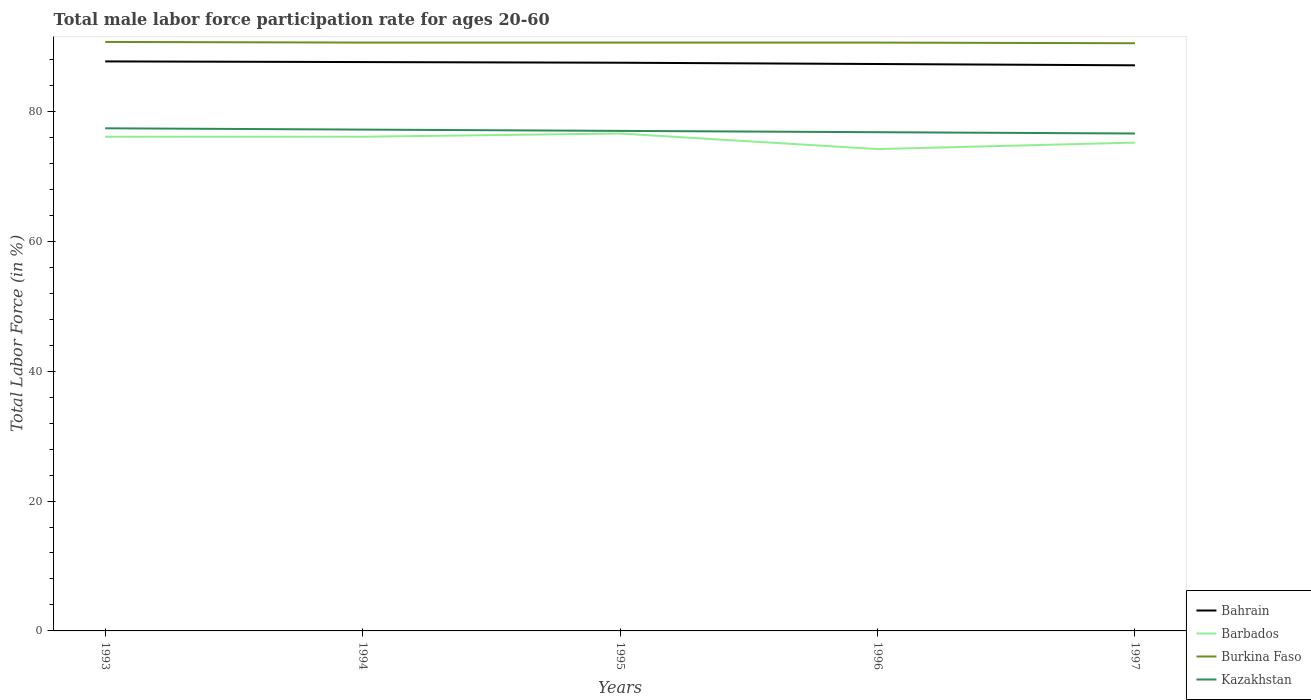How many different coloured lines are there?
Ensure brevity in your answer.  4. Does the line corresponding to Bahrain intersect with the line corresponding to Barbados?
Your answer should be very brief. No. Is the number of lines equal to the number of legend labels?
Provide a short and direct response. Yes. Across all years, what is the maximum male labor force participation rate in Kazakhstan?
Your answer should be compact. 76.6. What is the total male labor force participation rate in Barbados in the graph?
Ensure brevity in your answer.  0.9. What is the difference between the highest and the second highest male labor force participation rate in Burkina Faso?
Provide a succinct answer. 0.2. Is the male labor force participation rate in Burkina Faso strictly greater than the male labor force participation rate in Bahrain over the years?
Provide a short and direct response. No. What is the difference between two consecutive major ticks on the Y-axis?
Ensure brevity in your answer.  20. How many legend labels are there?
Offer a terse response. 4. What is the title of the graph?
Your answer should be compact. Total male labor force participation rate for ages 20-60. Does "United Arab Emirates" appear as one of the legend labels in the graph?
Offer a very short reply. No. What is the label or title of the Y-axis?
Your answer should be compact. Total Labor Force (in %). What is the Total Labor Force (in %) of Bahrain in 1993?
Offer a very short reply. 87.7. What is the Total Labor Force (in %) in Barbados in 1993?
Provide a succinct answer. 76.1. What is the Total Labor Force (in %) of Burkina Faso in 1993?
Provide a succinct answer. 90.7. What is the Total Labor Force (in %) of Kazakhstan in 1993?
Offer a terse response. 77.4. What is the Total Labor Force (in %) of Bahrain in 1994?
Give a very brief answer. 87.6. What is the Total Labor Force (in %) in Barbados in 1994?
Provide a succinct answer. 76.1. What is the Total Labor Force (in %) of Burkina Faso in 1994?
Your response must be concise. 90.6. What is the Total Labor Force (in %) in Kazakhstan in 1994?
Make the answer very short. 77.2. What is the Total Labor Force (in %) in Bahrain in 1995?
Keep it short and to the point. 87.5. What is the Total Labor Force (in %) in Barbados in 1995?
Provide a succinct answer. 76.6. What is the Total Labor Force (in %) in Burkina Faso in 1995?
Your response must be concise. 90.6. What is the Total Labor Force (in %) in Kazakhstan in 1995?
Your answer should be compact. 77. What is the Total Labor Force (in %) in Bahrain in 1996?
Offer a terse response. 87.3. What is the Total Labor Force (in %) of Barbados in 1996?
Offer a very short reply. 74.2. What is the Total Labor Force (in %) of Burkina Faso in 1996?
Ensure brevity in your answer.  90.6. What is the Total Labor Force (in %) in Kazakhstan in 1996?
Give a very brief answer. 76.8. What is the Total Labor Force (in %) in Bahrain in 1997?
Your response must be concise. 87.1. What is the Total Labor Force (in %) of Barbados in 1997?
Provide a short and direct response. 75.2. What is the Total Labor Force (in %) in Burkina Faso in 1997?
Ensure brevity in your answer.  90.5. What is the Total Labor Force (in %) in Kazakhstan in 1997?
Your response must be concise. 76.6. Across all years, what is the maximum Total Labor Force (in %) in Bahrain?
Give a very brief answer. 87.7. Across all years, what is the maximum Total Labor Force (in %) in Barbados?
Give a very brief answer. 76.6. Across all years, what is the maximum Total Labor Force (in %) of Burkina Faso?
Ensure brevity in your answer.  90.7. Across all years, what is the maximum Total Labor Force (in %) in Kazakhstan?
Offer a terse response. 77.4. Across all years, what is the minimum Total Labor Force (in %) in Bahrain?
Provide a short and direct response. 87.1. Across all years, what is the minimum Total Labor Force (in %) of Barbados?
Your response must be concise. 74.2. Across all years, what is the minimum Total Labor Force (in %) of Burkina Faso?
Keep it short and to the point. 90.5. Across all years, what is the minimum Total Labor Force (in %) in Kazakhstan?
Offer a terse response. 76.6. What is the total Total Labor Force (in %) of Bahrain in the graph?
Make the answer very short. 437.2. What is the total Total Labor Force (in %) of Barbados in the graph?
Your answer should be very brief. 378.2. What is the total Total Labor Force (in %) in Burkina Faso in the graph?
Offer a terse response. 453. What is the total Total Labor Force (in %) in Kazakhstan in the graph?
Your answer should be very brief. 385. What is the difference between the Total Labor Force (in %) of Bahrain in 1993 and that in 1994?
Your answer should be compact. 0.1. What is the difference between the Total Labor Force (in %) in Barbados in 1993 and that in 1995?
Ensure brevity in your answer.  -0.5. What is the difference between the Total Labor Force (in %) of Kazakhstan in 1993 and that in 1995?
Your answer should be very brief. 0.4. What is the difference between the Total Labor Force (in %) in Kazakhstan in 1993 and that in 1996?
Provide a succinct answer. 0.6. What is the difference between the Total Labor Force (in %) in Bahrain in 1993 and that in 1997?
Your answer should be very brief. 0.6. What is the difference between the Total Labor Force (in %) in Bahrain in 1994 and that in 1995?
Your answer should be very brief. 0.1. What is the difference between the Total Labor Force (in %) in Barbados in 1994 and that in 1995?
Keep it short and to the point. -0.5. What is the difference between the Total Labor Force (in %) of Burkina Faso in 1994 and that in 1996?
Provide a succinct answer. 0. What is the difference between the Total Labor Force (in %) in Kazakhstan in 1994 and that in 1996?
Provide a short and direct response. 0.4. What is the difference between the Total Labor Force (in %) of Bahrain in 1995 and that in 1996?
Keep it short and to the point. 0.2. What is the difference between the Total Labor Force (in %) in Barbados in 1995 and that in 1996?
Your response must be concise. 2.4. What is the difference between the Total Labor Force (in %) in Kazakhstan in 1995 and that in 1996?
Provide a succinct answer. 0.2. What is the difference between the Total Labor Force (in %) in Barbados in 1995 and that in 1997?
Keep it short and to the point. 1.4. What is the difference between the Total Labor Force (in %) in Kazakhstan in 1995 and that in 1997?
Your answer should be compact. 0.4. What is the difference between the Total Labor Force (in %) of Bahrain in 1996 and that in 1997?
Ensure brevity in your answer.  0.2. What is the difference between the Total Labor Force (in %) in Barbados in 1996 and that in 1997?
Your response must be concise. -1. What is the difference between the Total Labor Force (in %) in Burkina Faso in 1996 and that in 1997?
Make the answer very short. 0.1. What is the difference between the Total Labor Force (in %) of Bahrain in 1993 and the Total Labor Force (in %) of Barbados in 1994?
Ensure brevity in your answer.  11.6. What is the difference between the Total Labor Force (in %) of Barbados in 1993 and the Total Labor Force (in %) of Burkina Faso in 1994?
Give a very brief answer. -14.5. What is the difference between the Total Labor Force (in %) in Barbados in 1993 and the Total Labor Force (in %) in Kazakhstan in 1994?
Keep it short and to the point. -1.1. What is the difference between the Total Labor Force (in %) in Burkina Faso in 1993 and the Total Labor Force (in %) in Kazakhstan in 1994?
Your answer should be very brief. 13.5. What is the difference between the Total Labor Force (in %) in Bahrain in 1993 and the Total Labor Force (in %) in Barbados in 1995?
Provide a short and direct response. 11.1. What is the difference between the Total Labor Force (in %) of Bahrain in 1993 and the Total Labor Force (in %) of Kazakhstan in 1995?
Keep it short and to the point. 10.7. What is the difference between the Total Labor Force (in %) in Barbados in 1993 and the Total Labor Force (in %) in Burkina Faso in 1995?
Make the answer very short. -14.5. What is the difference between the Total Labor Force (in %) of Barbados in 1993 and the Total Labor Force (in %) of Kazakhstan in 1995?
Ensure brevity in your answer.  -0.9. What is the difference between the Total Labor Force (in %) of Bahrain in 1993 and the Total Labor Force (in %) of Burkina Faso in 1996?
Provide a short and direct response. -2.9. What is the difference between the Total Labor Force (in %) in Bahrain in 1993 and the Total Labor Force (in %) in Kazakhstan in 1996?
Your response must be concise. 10.9. What is the difference between the Total Labor Force (in %) in Barbados in 1993 and the Total Labor Force (in %) in Kazakhstan in 1996?
Give a very brief answer. -0.7. What is the difference between the Total Labor Force (in %) in Burkina Faso in 1993 and the Total Labor Force (in %) in Kazakhstan in 1996?
Keep it short and to the point. 13.9. What is the difference between the Total Labor Force (in %) of Bahrain in 1993 and the Total Labor Force (in %) of Barbados in 1997?
Provide a short and direct response. 12.5. What is the difference between the Total Labor Force (in %) of Bahrain in 1993 and the Total Labor Force (in %) of Burkina Faso in 1997?
Your answer should be very brief. -2.8. What is the difference between the Total Labor Force (in %) in Barbados in 1993 and the Total Labor Force (in %) in Burkina Faso in 1997?
Your answer should be very brief. -14.4. What is the difference between the Total Labor Force (in %) of Barbados in 1993 and the Total Labor Force (in %) of Kazakhstan in 1997?
Provide a short and direct response. -0.5. What is the difference between the Total Labor Force (in %) in Burkina Faso in 1993 and the Total Labor Force (in %) in Kazakhstan in 1997?
Your answer should be compact. 14.1. What is the difference between the Total Labor Force (in %) of Bahrain in 1994 and the Total Labor Force (in %) of Barbados in 1995?
Make the answer very short. 11. What is the difference between the Total Labor Force (in %) in Bahrain in 1994 and the Total Labor Force (in %) in Burkina Faso in 1995?
Ensure brevity in your answer.  -3. What is the difference between the Total Labor Force (in %) of Barbados in 1994 and the Total Labor Force (in %) of Burkina Faso in 1995?
Provide a succinct answer. -14.5. What is the difference between the Total Labor Force (in %) of Barbados in 1994 and the Total Labor Force (in %) of Kazakhstan in 1995?
Ensure brevity in your answer.  -0.9. What is the difference between the Total Labor Force (in %) in Burkina Faso in 1994 and the Total Labor Force (in %) in Kazakhstan in 1995?
Give a very brief answer. 13.6. What is the difference between the Total Labor Force (in %) in Bahrain in 1994 and the Total Labor Force (in %) in Burkina Faso in 1996?
Your answer should be very brief. -3. What is the difference between the Total Labor Force (in %) of Bahrain in 1994 and the Total Labor Force (in %) of Kazakhstan in 1996?
Make the answer very short. 10.8. What is the difference between the Total Labor Force (in %) of Barbados in 1994 and the Total Labor Force (in %) of Kazakhstan in 1996?
Make the answer very short. -0.7. What is the difference between the Total Labor Force (in %) in Burkina Faso in 1994 and the Total Labor Force (in %) in Kazakhstan in 1996?
Ensure brevity in your answer.  13.8. What is the difference between the Total Labor Force (in %) in Bahrain in 1994 and the Total Labor Force (in %) in Barbados in 1997?
Give a very brief answer. 12.4. What is the difference between the Total Labor Force (in %) in Bahrain in 1994 and the Total Labor Force (in %) in Burkina Faso in 1997?
Ensure brevity in your answer.  -2.9. What is the difference between the Total Labor Force (in %) of Bahrain in 1994 and the Total Labor Force (in %) of Kazakhstan in 1997?
Your answer should be very brief. 11. What is the difference between the Total Labor Force (in %) of Barbados in 1994 and the Total Labor Force (in %) of Burkina Faso in 1997?
Make the answer very short. -14.4. What is the difference between the Total Labor Force (in %) of Barbados in 1994 and the Total Labor Force (in %) of Kazakhstan in 1997?
Your answer should be compact. -0.5. What is the difference between the Total Labor Force (in %) in Bahrain in 1995 and the Total Labor Force (in %) in Kazakhstan in 1996?
Offer a very short reply. 10.7. What is the difference between the Total Labor Force (in %) in Barbados in 1995 and the Total Labor Force (in %) in Kazakhstan in 1996?
Your answer should be compact. -0.2. What is the difference between the Total Labor Force (in %) in Bahrain in 1995 and the Total Labor Force (in %) in Barbados in 1997?
Offer a very short reply. 12.3. What is the difference between the Total Labor Force (in %) of Bahrain in 1995 and the Total Labor Force (in %) of Burkina Faso in 1997?
Your response must be concise. -3. What is the difference between the Total Labor Force (in %) of Bahrain in 1995 and the Total Labor Force (in %) of Kazakhstan in 1997?
Your response must be concise. 10.9. What is the difference between the Total Labor Force (in %) of Bahrain in 1996 and the Total Labor Force (in %) of Barbados in 1997?
Provide a short and direct response. 12.1. What is the difference between the Total Labor Force (in %) of Barbados in 1996 and the Total Labor Force (in %) of Burkina Faso in 1997?
Provide a short and direct response. -16.3. What is the average Total Labor Force (in %) of Bahrain per year?
Offer a terse response. 87.44. What is the average Total Labor Force (in %) of Barbados per year?
Ensure brevity in your answer.  75.64. What is the average Total Labor Force (in %) in Burkina Faso per year?
Your response must be concise. 90.6. What is the average Total Labor Force (in %) in Kazakhstan per year?
Your answer should be very brief. 77. In the year 1993, what is the difference between the Total Labor Force (in %) in Bahrain and Total Labor Force (in %) in Burkina Faso?
Ensure brevity in your answer.  -3. In the year 1993, what is the difference between the Total Labor Force (in %) in Bahrain and Total Labor Force (in %) in Kazakhstan?
Keep it short and to the point. 10.3. In the year 1993, what is the difference between the Total Labor Force (in %) in Barbados and Total Labor Force (in %) in Burkina Faso?
Ensure brevity in your answer.  -14.6. In the year 1993, what is the difference between the Total Labor Force (in %) in Barbados and Total Labor Force (in %) in Kazakhstan?
Your answer should be very brief. -1.3. In the year 1993, what is the difference between the Total Labor Force (in %) of Burkina Faso and Total Labor Force (in %) of Kazakhstan?
Your answer should be very brief. 13.3. In the year 1994, what is the difference between the Total Labor Force (in %) of Bahrain and Total Labor Force (in %) of Barbados?
Your answer should be very brief. 11.5. In the year 1994, what is the difference between the Total Labor Force (in %) in Barbados and Total Labor Force (in %) in Burkina Faso?
Your answer should be very brief. -14.5. In the year 1994, what is the difference between the Total Labor Force (in %) in Burkina Faso and Total Labor Force (in %) in Kazakhstan?
Provide a succinct answer. 13.4. In the year 1995, what is the difference between the Total Labor Force (in %) of Bahrain and Total Labor Force (in %) of Kazakhstan?
Your answer should be compact. 10.5. In the year 1995, what is the difference between the Total Labor Force (in %) in Barbados and Total Labor Force (in %) in Kazakhstan?
Give a very brief answer. -0.4. In the year 1996, what is the difference between the Total Labor Force (in %) in Barbados and Total Labor Force (in %) in Burkina Faso?
Your answer should be compact. -16.4. In the year 1996, what is the difference between the Total Labor Force (in %) in Barbados and Total Labor Force (in %) in Kazakhstan?
Your response must be concise. -2.6. In the year 1997, what is the difference between the Total Labor Force (in %) of Bahrain and Total Labor Force (in %) of Kazakhstan?
Keep it short and to the point. 10.5. In the year 1997, what is the difference between the Total Labor Force (in %) in Barbados and Total Labor Force (in %) in Burkina Faso?
Keep it short and to the point. -15.3. In the year 1997, what is the difference between the Total Labor Force (in %) in Barbados and Total Labor Force (in %) in Kazakhstan?
Provide a short and direct response. -1.4. In the year 1997, what is the difference between the Total Labor Force (in %) in Burkina Faso and Total Labor Force (in %) in Kazakhstan?
Your answer should be very brief. 13.9. What is the ratio of the Total Labor Force (in %) of Bahrain in 1993 to that in 1994?
Your answer should be very brief. 1. What is the ratio of the Total Labor Force (in %) of Burkina Faso in 1993 to that in 1994?
Ensure brevity in your answer.  1. What is the ratio of the Total Labor Force (in %) in Burkina Faso in 1993 to that in 1995?
Your answer should be very brief. 1. What is the ratio of the Total Labor Force (in %) of Barbados in 1993 to that in 1996?
Ensure brevity in your answer.  1.03. What is the ratio of the Total Labor Force (in %) of Burkina Faso in 1993 to that in 1996?
Your response must be concise. 1. What is the ratio of the Total Labor Force (in %) in Barbados in 1993 to that in 1997?
Ensure brevity in your answer.  1.01. What is the ratio of the Total Labor Force (in %) in Kazakhstan in 1993 to that in 1997?
Ensure brevity in your answer.  1.01. What is the ratio of the Total Labor Force (in %) in Burkina Faso in 1994 to that in 1995?
Keep it short and to the point. 1. What is the ratio of the Total Labor Force (in %) of Kazakhstan in 1994 to that in 1995?
Provide a short and direct response. 1. What is the ratio of the Total Labor Force (in %) of Barbados in 1994 to that in 1996?
Ensure brevity in your answer.  1.03. What is the ratio of the Total Labor Force (in %) of Kazakhstan in 1994 to that in 1997?
Your response must be concise. 1.01. What is the ratio of the Total Labor Force (in %) of Barbados in 1995 to that in 1996?
Your answer should be compact. 1.03. What is the ratio of the Total Labor Force (in %) in Kazakhstan in 1995 to that in 1996?
Your response must be concise. 1. What is the ratio of the Total Labor Force (in %) of Bahrain in 1995 to that in 1997?
Make the answer very short. 1. What is the ratio of the Total Labor Force (in %) of Barbados in 1995 to that in 1997?
Your answer should be compact. 1.02. What is the ratio of the Total Labor Force (in %) of Burkina Faso in 1995 to that in 1997?
Keep it short and to the point. 1. What is the ratio of the Total Labor Force (in %) of Barbados in 1996 to that in 1997?
Your answer should be compact. 0.99. What is the ratio of the Total Labor Force (in %) of Burkina Faso in 1996 to that in 1997?
Make the answer very short. 1. What is the difference between the highest and the second highest Total Labor Force (in %) of Kazakhstan?
Your answer should be very brief. 0.2. What is the difference between the highest and the lowest Total Labor Force (in %) of Bahrain?
Your response must be concise. 0.6. What is the difference between the highest and the lowest Total Labor Force (in %) in Burkina Faso?
Keep it short and to the point. 0.2. 